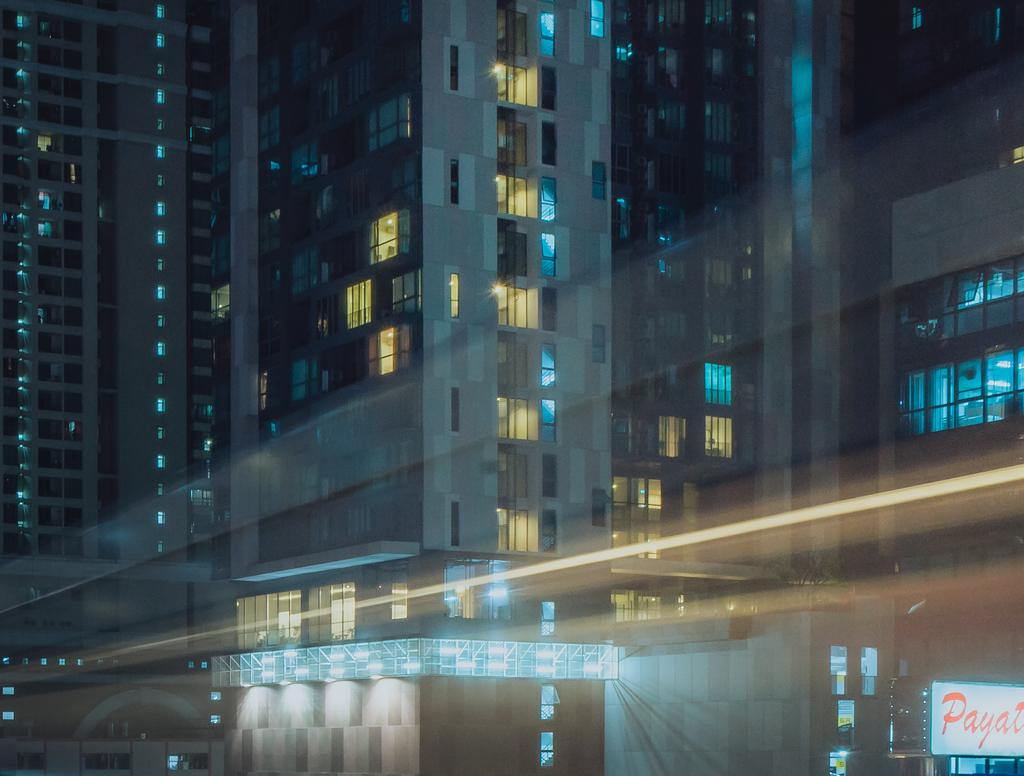What type of structures are visible in the image? There are buildings with windows in the image. Can you describe any additional features of the buildings? The provided facts do not mention any additional features of the buildings. What is located on the right side bottom of the image? There is an advertisement board with text on the right side bottom of the image. What type of rhythm can be heard coming from the buildings in the image? There is no indication of sound or rhythm in the image, as it only features buildings and an advertisement board. 